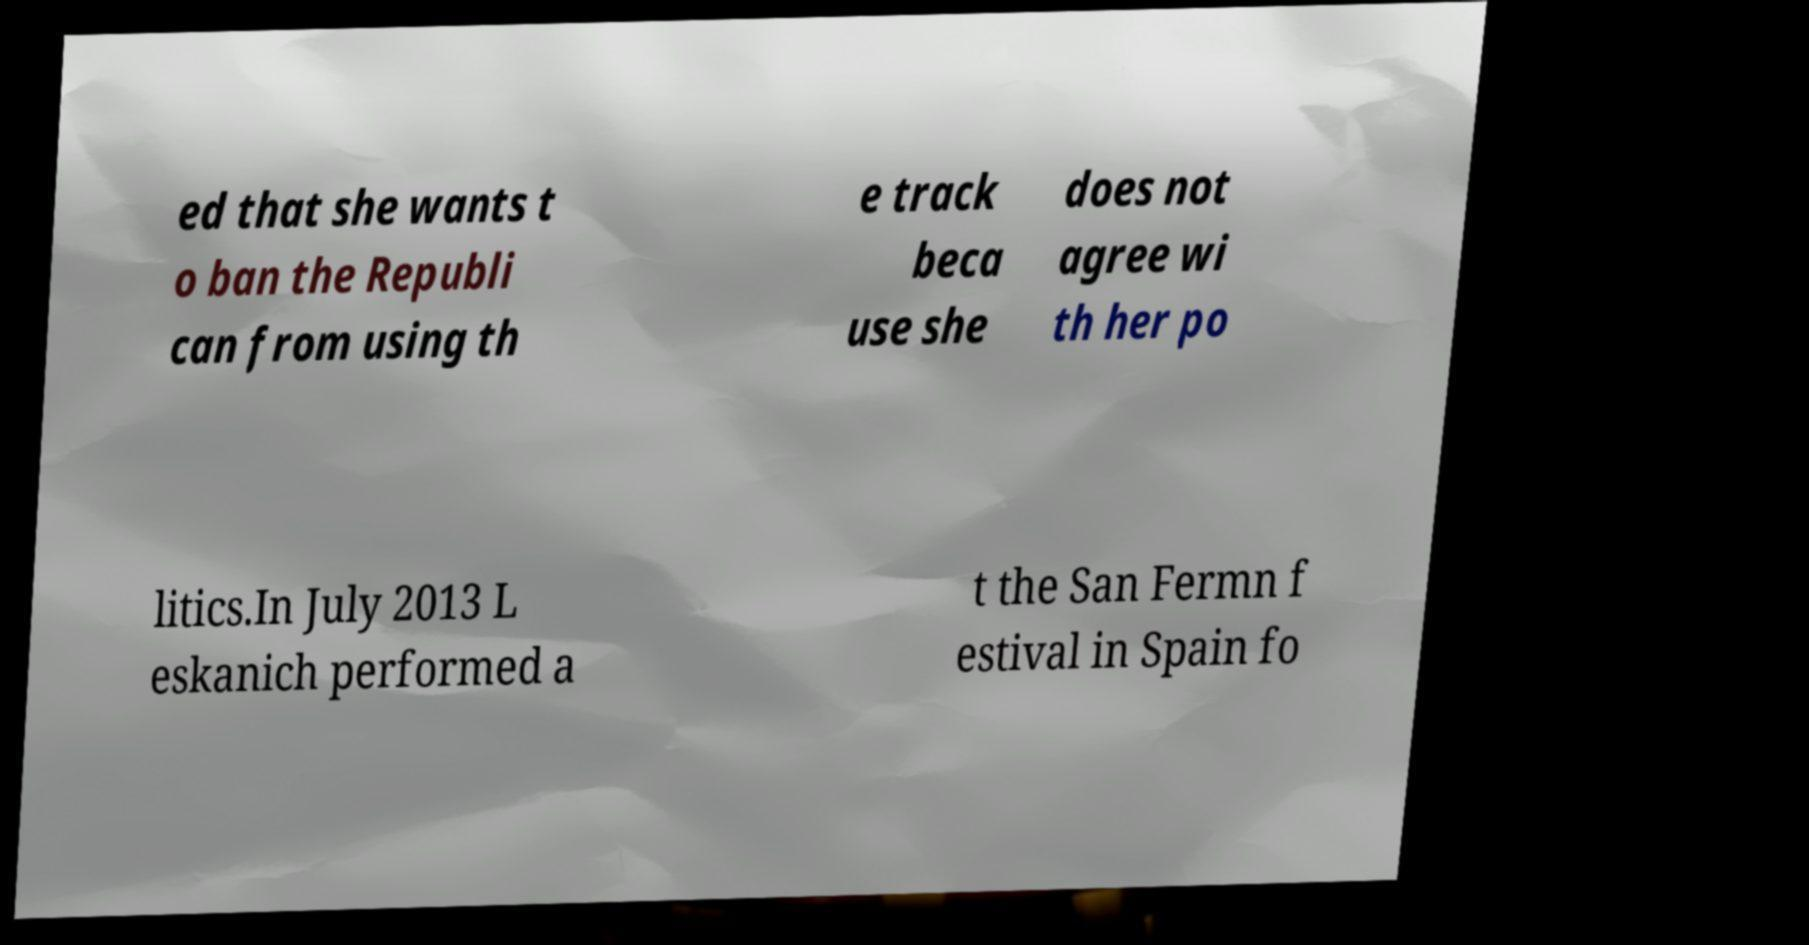Can you read and provide the text displayed in the image?This photo seems to have some interesting text. Can you extract and type it out for me? ed that she wants t o ban the Republi can from using th e track beca use she does not agree wi th her po litics.In July 2013 L eskanich performed a t the San Fermn f estival in Spain fo 